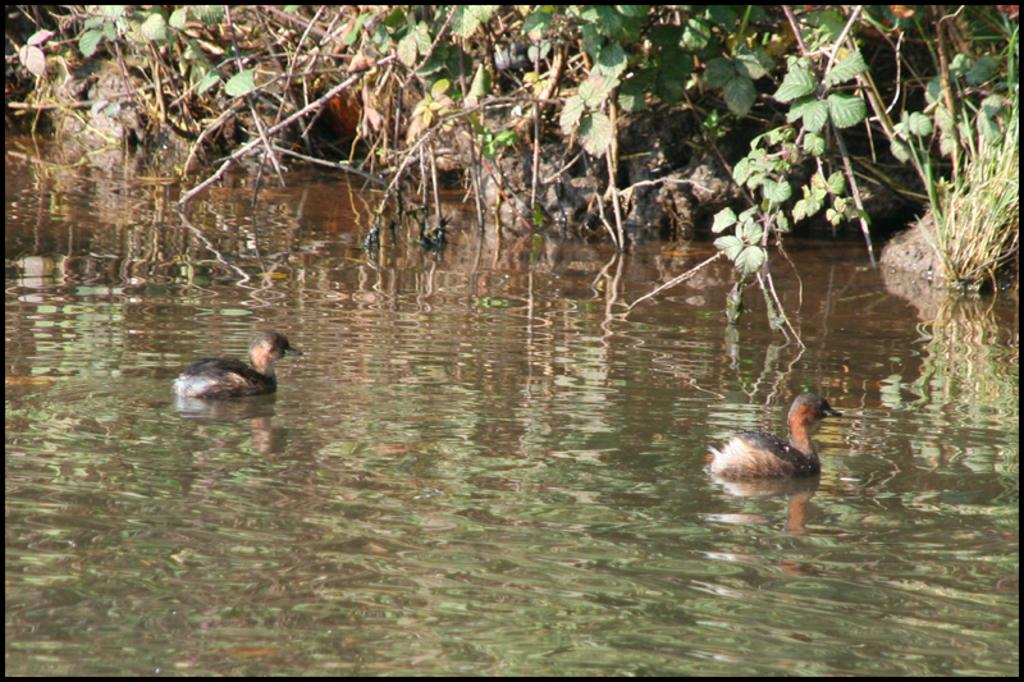What type of animals can be seen in the water in the image? There are ducks in the water in the image. What can be seen in the background of the image? Trees are visible at the top of the image. What color is the eye of the bat in the image? There is no bat present in the image, so it is not possible to determine the color of its eye. 